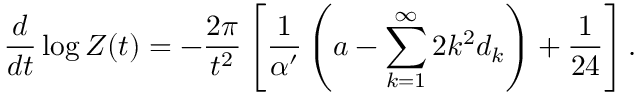Convert formula to latex. <formula><loc_0><loc_0><loc_500><loc_500>\frac { d } d t } \log Z ( t ) = - \frac { 2 \pi } { t ^ { 2 } } \left [ \frac { 1 } \alpha ^ { \prime } } \left ( a - \sum _ { k = 1 } ^ { \infty } 2 k ^ { 2 } d _ { k } \right ) + \frac { 1 } 2 4 } \right ] .</formula> 